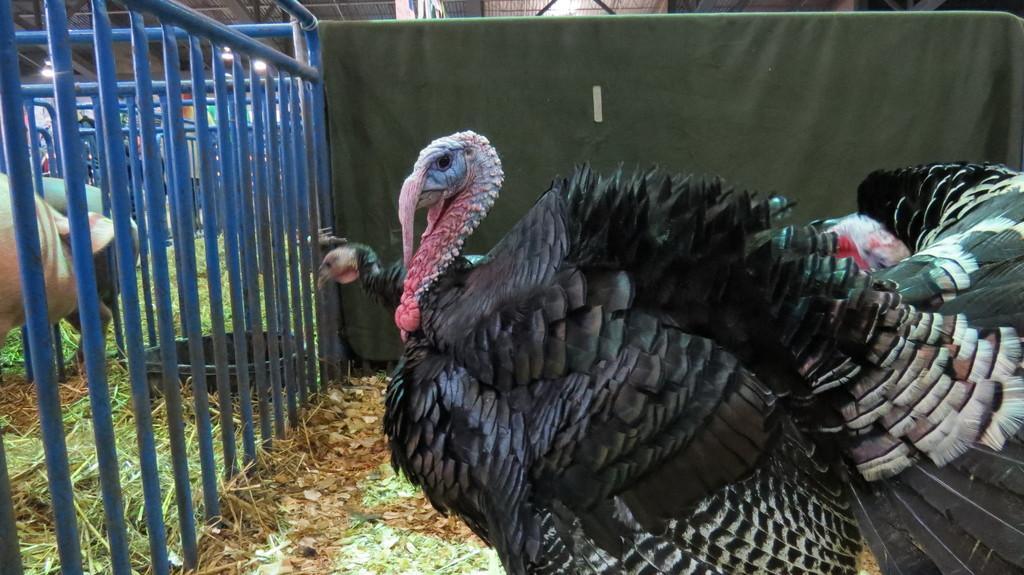In one or two sentences, can you explain what this image depicts? This image is taken indoors. At the bottom of the image there is a ground with grass on it. At the top of the image there is a roof. In the middle of the image there are two turkeys on the ground. On the left side of the image there are a few railings and there are two animals. 